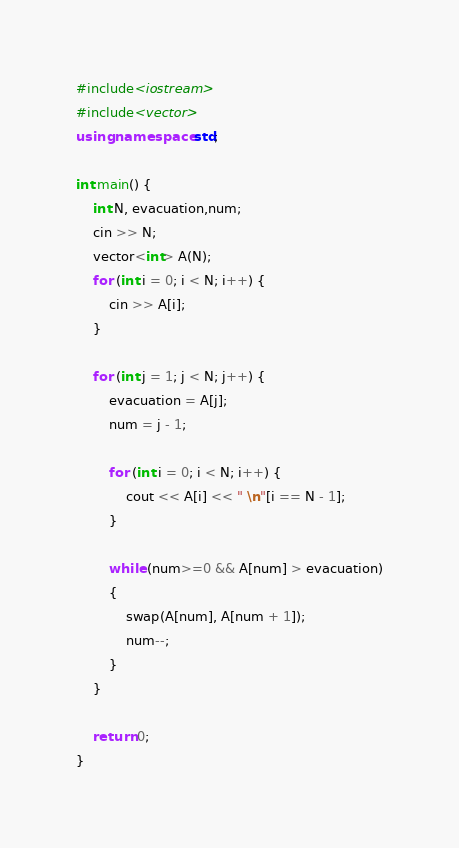<code> <loc_0><loc_0><loc_500><loc_500><_C++_>#include<iostream>
#include<vector>
using namespace std;

int main() {
	int N, evacuation,num;
	cin >> N;
	vector<int> A(N);
	for (int i = 0; i < N; i++) {
		cin >> A[i];
	}

	for (int j = 1; j < N; j++) {
		evacuation = A[j];
		num = j - 1;

		for (int i = 0; i < N; i++) {
			cout << A[i] << " \n"[i == N - 1];
		}

		while (num>=0 && A[num] > evacuation)
		{
			swap(A[num], A[num + 1]);
			num--;
		}
	}

	return 0;
}


</code> 